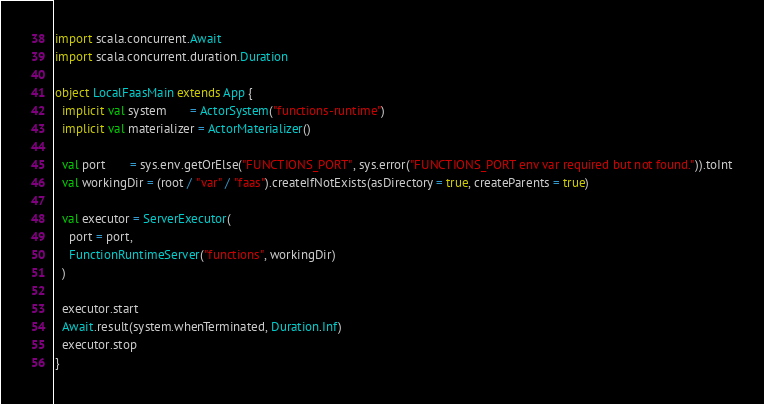<code> <loc_0><loc_0><loc_500><loc_500><_Scala_>import scala.concurrent.Await
import scala.concurrent.duration.Duration

object LocalFaasMain extends App {
  implicit val system       = ActorSystem("functions-runtime")
  implicit val materializer = ActorMaterializer()

  val port       = sys.env.getOrElse("FUNCTIONS_PORT", sys.error("FUNCTIONS_PORT env var required but not found.")).toInt
  val workingDir = (root / "var" / "faas").createIfNotExists(asDirectory = true, createParents = true)

  val executor = ServerExecutor(
    port = port,
    FunctionRuntimeServer("functions", workingDir)
  )

  executor.start
  Await.result(system.whenTerminated, Duration.Inf)
  executor.stop
}
</code> 